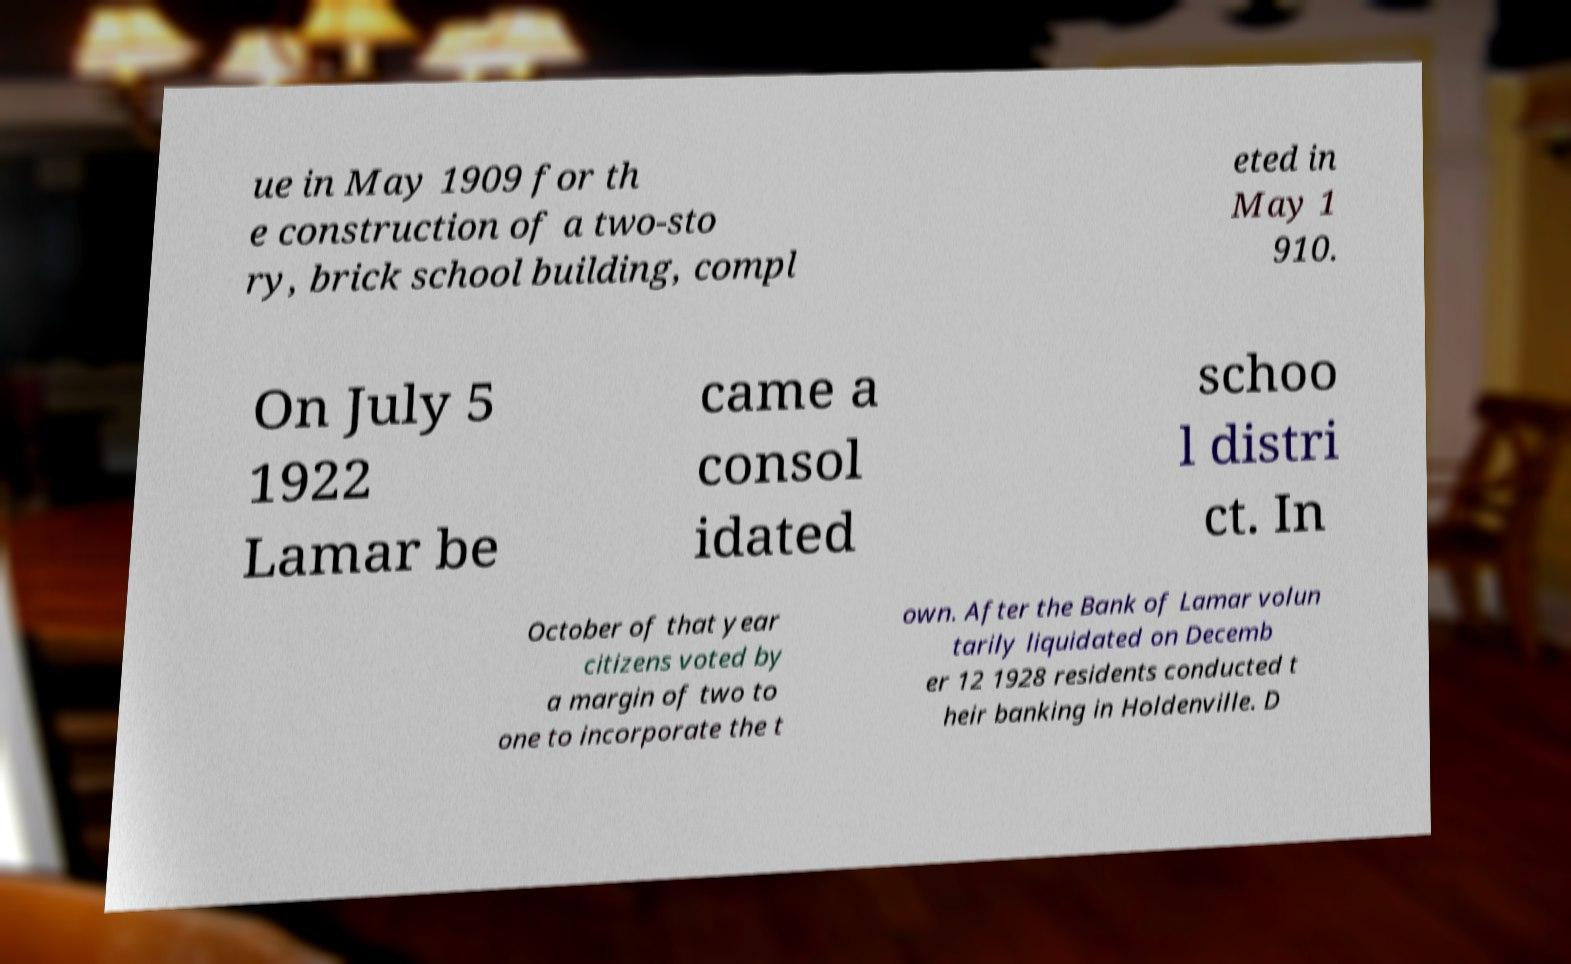What messages or text are displayed in this image? I need them in a readable, typed format. ue in May 1909 for th e construction of a two-sto ry, brick school building, compl eted in May 1 910. On July 5 1922 Lamar be came a consol idated schoo l distri ct. In October of that year citizens voted by a margin of two to one to incorporate the t own. After the Bank of Lamar volun tarily liquidated on Decemb er 12 1928 residents conducted t heir banking in Holdenville. D 